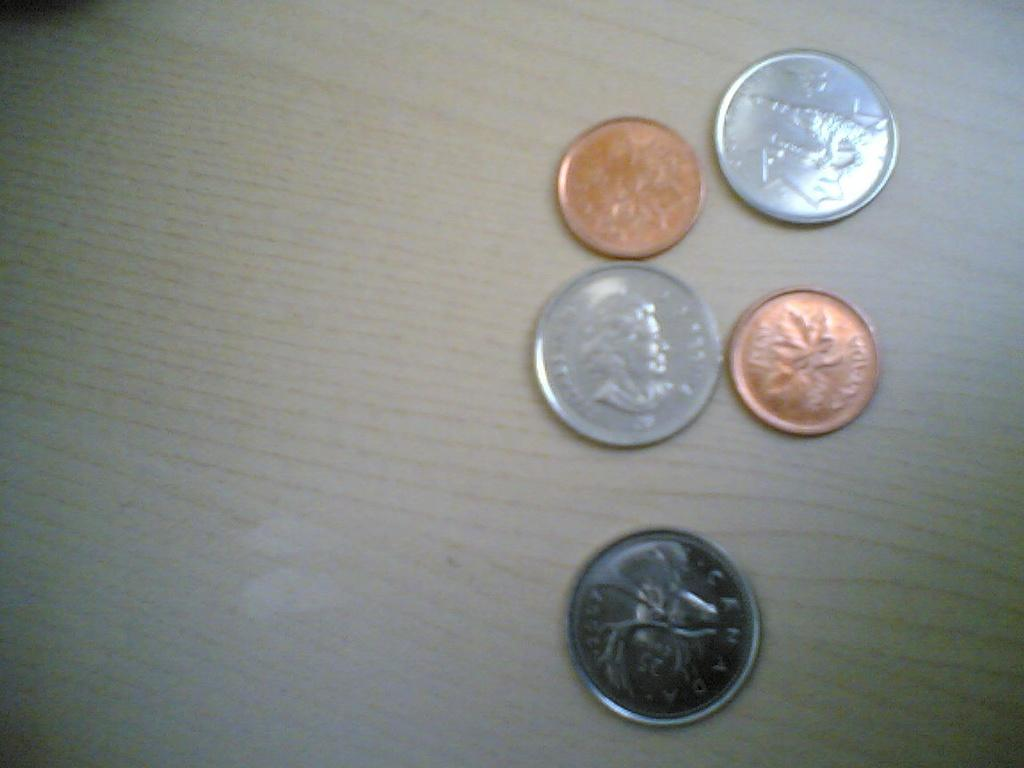Provide a one-sentence caption for the provided image. A penny with a maple leaf and the word CANADA sits with some other coins on a table. 